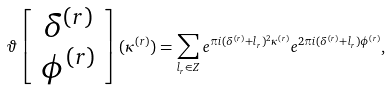<formula> <loc_0><loc_0><loc_500><loc_500>\vartheta \left [ \begin{array} { c } \delta ^ { ( r ) } \\ \phi ^ { ( r ) } \end{array} \right ] ( \kappa ^ { ( r ) } ) = \sum _ { l _ { r } \in Z } e ^ { \pi i ( \delta ^ { ( r ) } + l _ { r } ) ^ { 2 } \kappa ^ { ( r ) } } e ^ { 2 \pi i ( \delta ^ { ( r ) } + l _ { r } ) \phi ^ { ( r ) } } , \,</formula> 